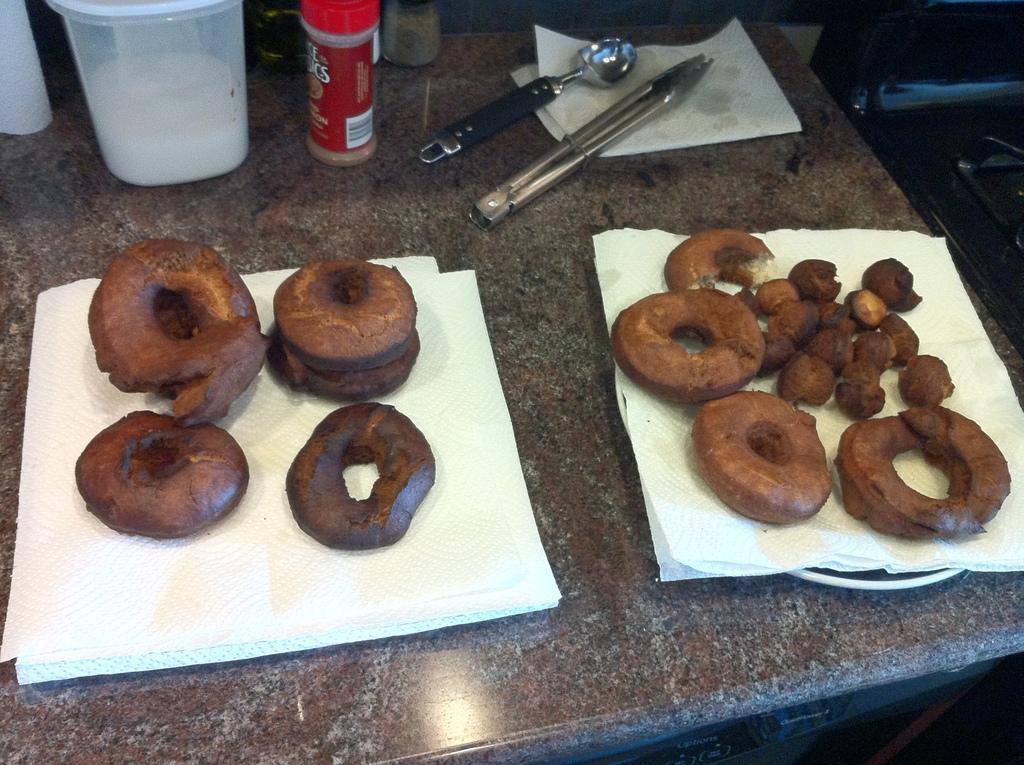Please provide a concise description of this image. In this image, we can see doughnuts, tissues, plates, jars and some holders on the table. In the background, there is an object. 